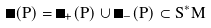Convert formula to latex. <formula><loc_0><loc_0><loc_500><loc_500>\Sigma ( P ) = \Sigma _ { + } ( P ) \cup \Sigma _ { - } ( P ) \subset S ^ { * } M</formula> 